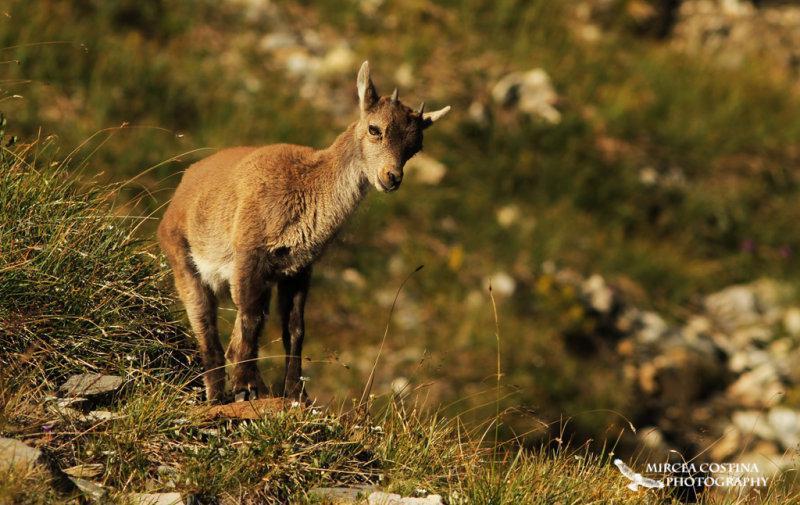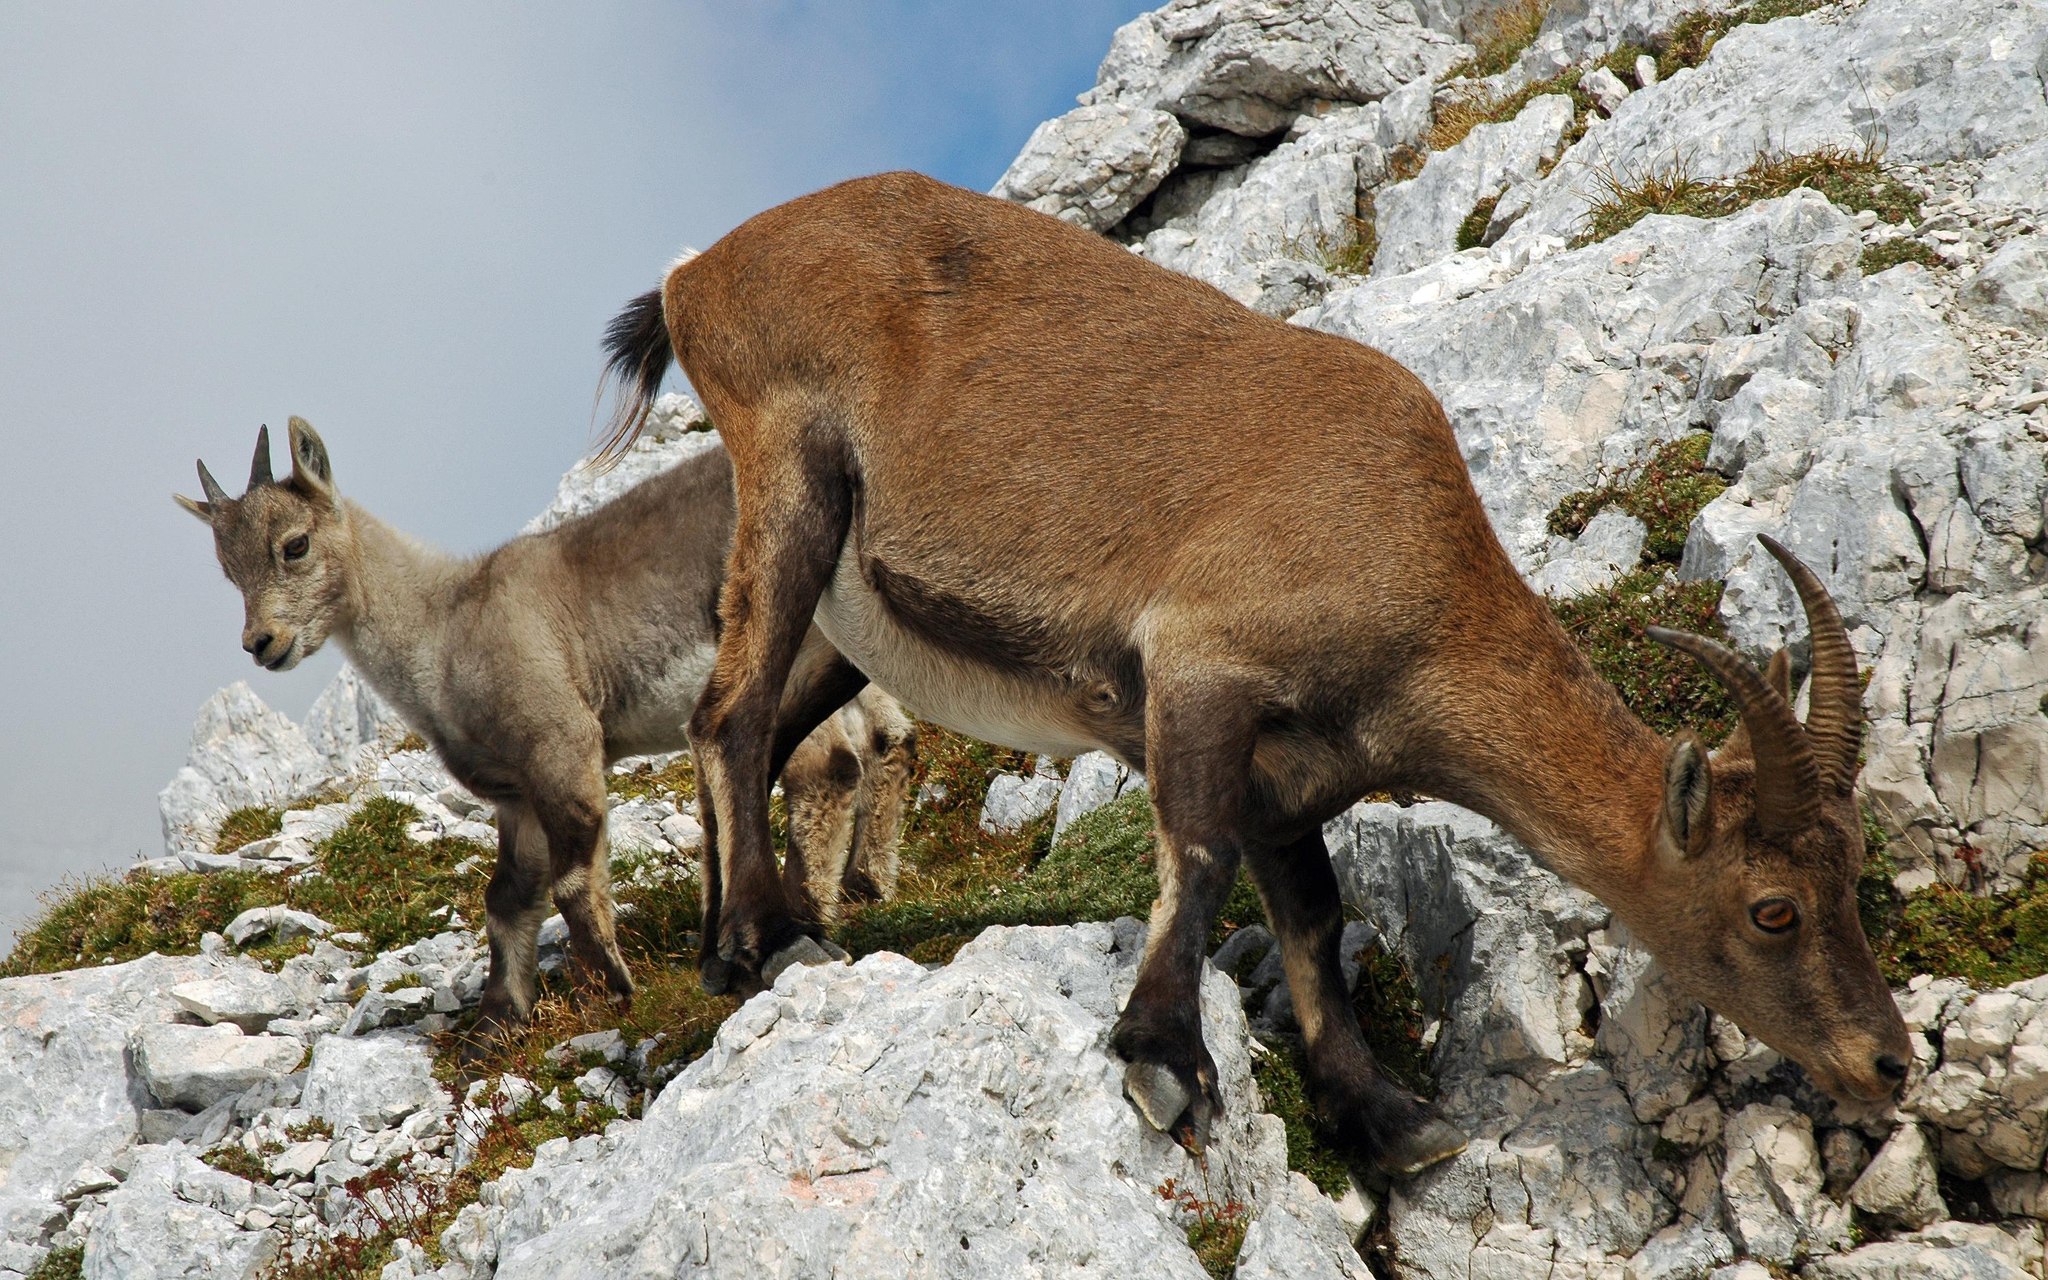The first image is the image on the left, the second image is the image on the right. Evaluate the accuracy of this statement regarding the images: "The left image contains exactly two mountain goats.". Is it true? Answer yes or no. No. The first image is the image on the left, the second image is the image on the right. Examine the images to the left and right. Is the description "There are two animals in the image on the left." accurate? Answer yes or no. No. 